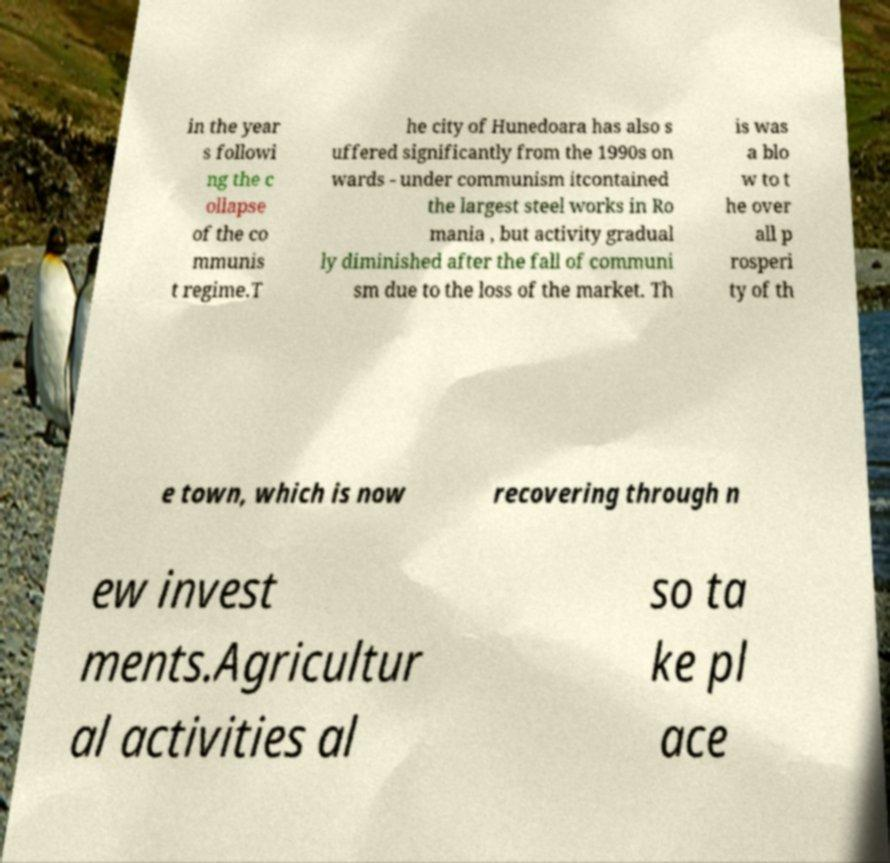For documentation purposes, I need the text within this image transcribed. Could you provide that? in the year s followi ng the c ollapse of the co mmunis t regime.T he city of Hunedoara has also s uffered significantly from the 1990s on wards - under communism itcontained the largest steel works in Ro mania , but activity gradual ly diminished after the fall of communi sm due to the loss of the market. Th is was a blo w to t he over all p rosperi ty of th e town, which is now recovering through n ew invest ments.Agricultur al activities al so ta ke pl ace 